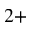<formula> <loc_0><loc_0><loc_500><loc_500>^ { 2 + }</formula> 